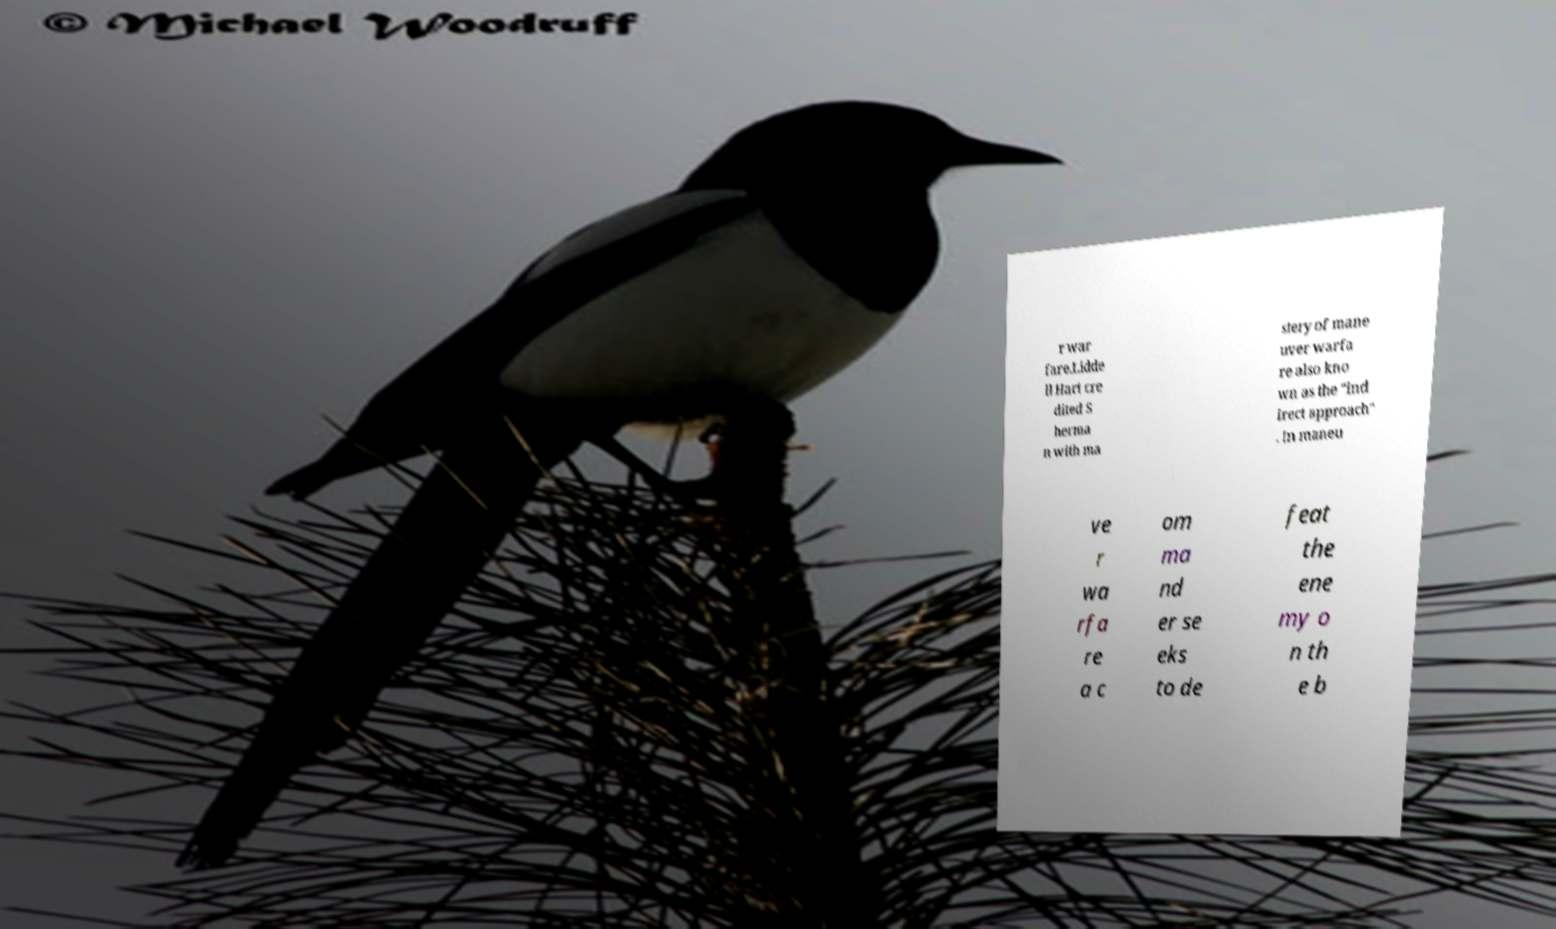Please identify and transcribe the text found in this image. r war fare.Lidde ll Hart cre dited S herma n with ma stery of mane uver warfa re also kno wn as the "ind irect approach" . In maneu ve r wa rfa re a c om ma nd er se eks to de feat the ene my o n th e b 